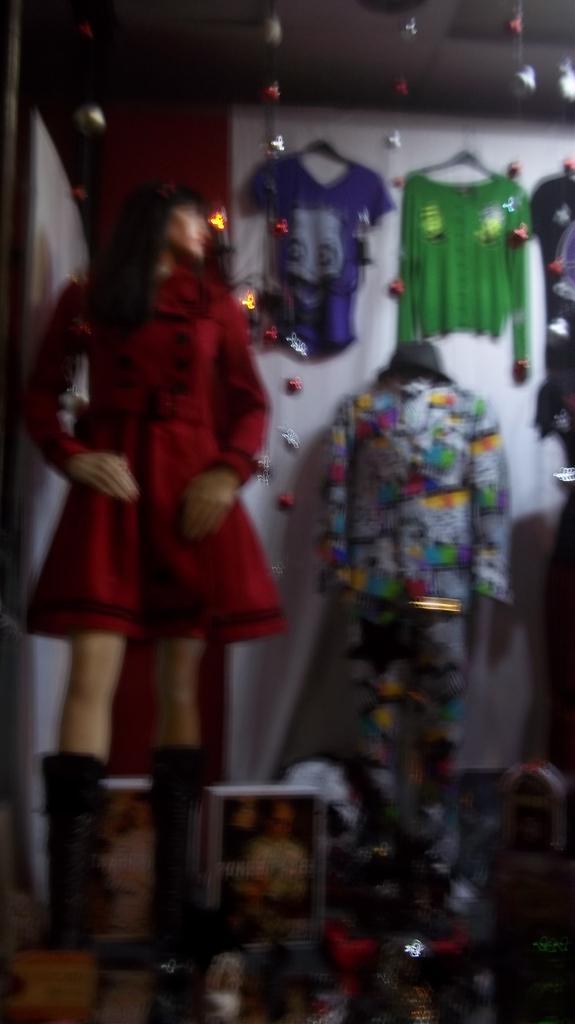In one or two sentences, can you explain what this image depicts? In this picture we can see mannequins, clothes, decor, wall are present. At the top of the image roof is there. At the bottom of the image floor is there. 